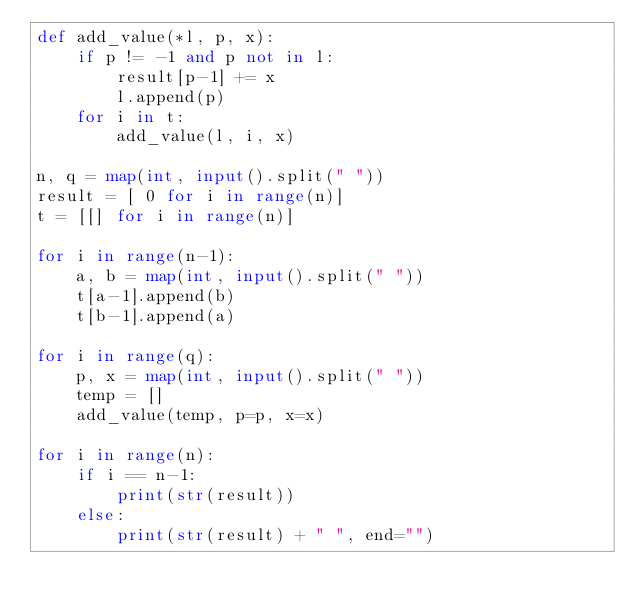<code> <loc_0><loc_0><loc_500><loc_500><_Python_>def add_value(*l, p, x):
    if p != -1 and p not in l:
        result[p-1] += x
        l.append(p)
    for i in t:
        add_value(l, i, x)        

n, q = map(int, input().split(" "))
result = [ 0 for i in range(n)]
t = [[] for i in range(n)]

for i in range(n-1):
    a, b = map(int, input().split(" "))
    t[a-1].append(b)
    t[b-1].append(a)

for i in range(q):
    p, x = map(int, input().split(" "))
    temp = []
    add_value(temp, p=p, x=x)

for i in range(n):
    if i == n-1:
        print(str(result))
    else:
        print(str(result) + " ", end="")
</code> 